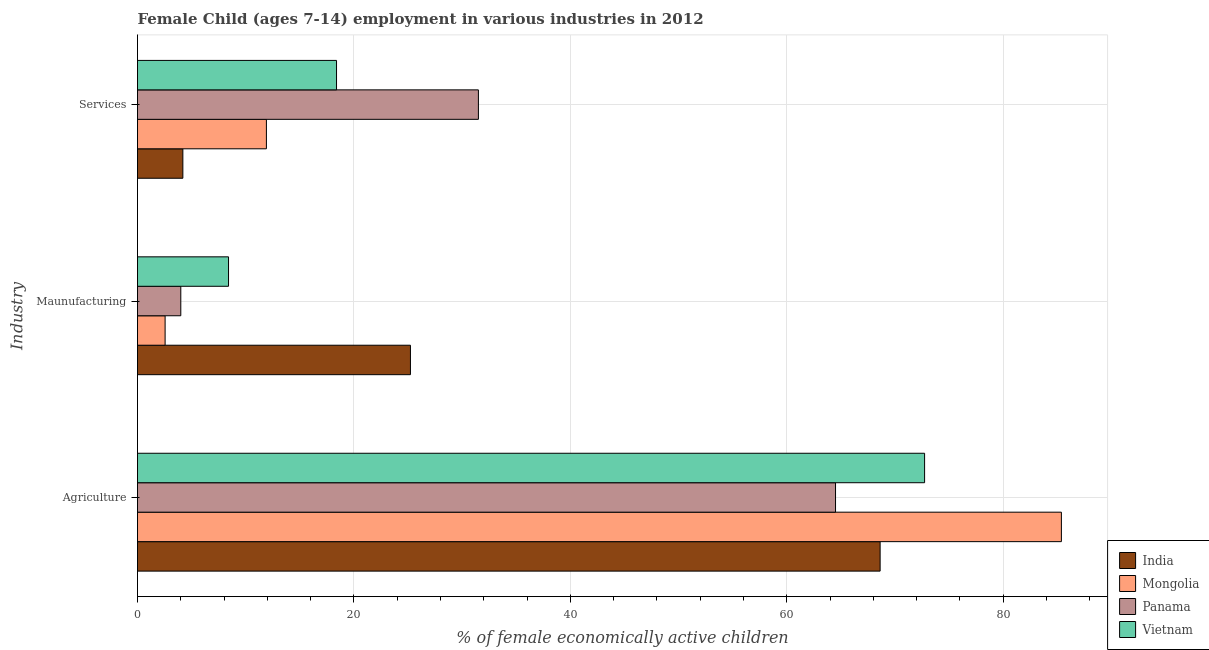How many different coloured bars are there?
Make the answer very short. 4. How many groups of bars are there?
Offer a very short reply. 3. Are the number of bars per tick equal to the number of legend labels?
Your answer should be compact. Yes. How many bars are there on the 2nd tick from the top?
Keep it short and to the point. 4. What is the label of the 3rd group of bars from the top?
Offer a terse response. Agriculture. What is the percentage of economically active children in agriculture in India?
Ensure brevity in your answer.  68.62. Across all countries, what is the maximum percentage of economically active children in manufacturing?
Your answer should be very brief. 25.22. Across all countries, what is the minimum percentage of economically active children in services?
Your response must be concise. 4.19. In which country was the percentage of economically active children in agriculture maximum?
Keep it short and to the point. Mongolia. In which country was the percentage of economically active children in services minimum?
Offer a terse response. India. What is the total percentage of economically active children in manufacturing in the graph?
Offer a very short reply. 40.18. What is the difference between the percentage of economically active children in services in India and that in Mongolia?
Provide a succinct answer. -7.72. What is the difference between the percentage of economically active children in manufacturing in India and the percentage of economically active children in services in Mongolia?
Provide a succinct answer. 13.31. What is the average percentage of economically active children in services per country?
Ensure brevity in your answer.  16.5. What is the difference between the percentage of economically active children in agriculture and percentage of economically active children in services in Vietnam?
Your answer should be compact. 54.34. What is the ratio of the percentage of economically active children in services in Vietnam to that in Mongolia?
Offer a terse response. 1.54. What is the difference between the highest and the second highest percentage of economically active children in services?
Provide a short and direct response. 13.11. What is the difference between the highest and the lowest percentage of economically active children in agriculture?
Offer a very short reply. 20.87. In how many countries, is the percentage of economically active children in manufacturing greater than the average percentage of economically active children in manufacturing taken over all countries?
Your answer should be very brief. 1. Is the sum of the percentage of economically active children in manufacturing in Vietnam and India greater than the maximum percentage of economically active children in services across all countries?
Provide a succinct answer. Yes. What does the 2nd bar from the top in Services represents?
Make the answer very short. Panama. What does the 1st bar from the bottom in Services represents?
Provide a succinct answer. India. Is it the case that in every country, the sum of the percentage of economically active children in agriculture and percentage of economically active children in manufacturing is greater than the percentage of economically active children in services?
Provide a short and direct response. Yes. How many bars are there?
Your response must be concise. 12. How many countries are there in the graph?
Keep it short and to the point. 4. Are the values on the major ticks of X-axis written in scientific E-notation?
Your answer should be very brief. No. Where does the legend appear in the graph?
Give a very brief answer. Bottom right. How are the legend labels stacked?
Provide a short and direct response. Vertical. What is the title of the graph?
Provide a succinct answer. Female Child (ages 7-14) employment in various industries in 2012. Does "Libya" appear as one of the legend labels in the graph?
Ensure brevity in your answer.  No. What is the label or title of the X-axis?
Your response must be concise. % of female economically active children. What is the label or title of the Y-axis?
Make the answer very short. Industry. What is the % of female economically active children in India in Agriculture?
Ensure brevity in your answer.  68.62. What is the % of female economically active children in Mongolia in Agriculture?
Provide a short and direct response. 85.37. What is the % of female economically active children of Panama in Agriculture?
Make the answer very short. 64.5. What is the % of female economically active children of Vietnam in Agriculture?
Make the answer very short. 72.73. What is the % of female economically active children of India in Maunufacturing?
Keep it short and to the point. 25.22. What is the % of female economically active children of Mongolia in Maunufacturing?
Ensure brevity in your answer.  2.55. What is the % of female economically active children in Panama in Maunufacturing?
Make the answer very short. 4. What is the % of female economically active children in Vietnam in Maunufacturing?
Make the answer very short. 8.41. What is the % of female economically active children in India in Services?
Make the answer very short. 4.19. What is the % of female economically active children of Mongolia in Services?
Provide a succinct answer. 11.91. What is the % of female economically active children in Panama in Services?
Ensure brevity in your answer.  31.5. What is the % of female economically active children in Vietnam in Services?
Offer a terse response. 18.39. Across all Industry, what is the maximum % of female economically active children in India?
Ensure brevity in your answer.  68.62. Across all Industry, what is the maximum % of female economically active children in Mongolia?
Offer a very short reply. 85.37. Across all Industry, what is the maximum % of female economically active children in Panama?
Your answer should be compact. 64.5. Across all Industry, what is the maximum % of female economically active children in Vietnam?
Provide a short and direct response. 72.73. Across all Industry, what is the minimum % of female economically active children in India?
Give a very brief answer. 4.19. Across all Industry, what is the minimum % of female economically active children of Mongolia?
Your answer should be very brief. 2.55. Across all Industry, what is the minimum % of female economically active children of Vietnam?
Provide a short and direct response. 8.41. What is the total % of female economically active children in India in the graph?
Your response must be concise. 98.03. What is the total % of female economically active children in Mongolia in the graph?
Keep it short and to the point. 99.83. What is the total % of female economically active children in Panama in the graph?
Your response must be concise. 100. What is the total % of female economically active children in Vietnam in the graph?
Your answer should be very brief. 99.53. What is the difference between the % of female economically active children in India in Agriculture and that in Maunufacturing?
Ensure brevity in your answer.  43.4. What is the difference between the % of female economically active children of Mongolia in Agriculture and that in Maunufacturing?
Your response must be concise. 82.82. What is the difference between the % of female economically active children in Panama in Agriculture and that in Maunufacturing?
Your response must be concise. 60.5. What is the difference between the % of female economically active children of Vietnam in Agriculture and that in Maunufacturing?
Keep it short and to the point. 64.32. What is the difference between the % of female economically active children of India in Agriculture and that in Services?
Your response must be concise. 64.43. What is the difference between the % of female economically active children in Mongolia in Agriculture and that in Services?
Your response must be concise. 73.46. What is the difference between the % of female economically active children of Vietnam in Agriculture and that in Services?
Provide a short and direct response. 54.34. What is the difference between the % of female economically active children in India in Maunufacturing and that in Services?
Your response must be concise. 21.03. What is the difference between the % of female economically active children of Mongolia in Maunufacturing and that in Services?
Make the answer very short. -9.36. What is the difference between the % of female economically active children of Panama in Maunufacturing and that in Services?
Your answer should be very brief. -27.5. What is the difference between the % of female economically active children in Vietnam in Maunufacturing and that in Services?
Offer a terse response. -9.98. What is the difference between the % of female economically active children in India in Agriculture and the % of female economically active children in Mongolia in Maunufacturing?
Offer a terse response. 66.07. What is the difference between the % of female economically active children of India in Agriculture and the % of female economically active children of Panama in Maunufacturing?
Your answer should be compact. 64.62. What is the difference between the % of female economically active children of India in Agriculture and the % of female economically active children of Vietnam in Maunufacturing?
Offer a terse response. 60.21. What is the difference between the % of female economically active children in Mongolia in Agriculture and the % of female economically active children in Panama in Maunufacturing?
Your response must be concise. 81.37. What is the difference between the % of female economically active children of Mongolia in Agriculture and the % of female economically active children of Vietnam in Maunufacturing?
Provide a succinct answer. 76.96. What is the difference between the % of female economically active children in Panama in Agriculture and the % of female economically active children in Vietnam in Maunufacturing?
Make the answer very short. 56.09. What is the difference between the % of female economically active children of India in Agriculture and the % of female economically active children of Mongolia in Services?
Ensure brevity in your answer.  56.71. What is the difference between the % of female economically active children in India in Agriculture and the % of female economically active children in Panama in Services?
Make the answer very short. 37.12. What is the difference between the % of female economically active children of India in Agriculture and the % of female economically active children of Vietnam in Services?
Ensure brevity in your answer.  50.23. What is the difference between the % of female economically active children in Mongolia in Agriculture and the % of female economically active children in Panama in Services?
Give a very brief answer. 53.87. What is the difference between the % of female economically active children of Mongolia in Agriculture and the % of female economically active children of Vietnam in Services?
Provide a succinct answer. 66.98. What is the difference between the % of female economically active children of Panama in Agriculture and the % of female economically active children of Vietnam in Services?
Offer a terse response. 46.11. What is the difference between the % of female economically active children in India in Maunufacturing and the % of female economically active children in Mongolia in Services?
Make the answer very short. 13.31. What is the difference between the % of female economically active children of India in Maunufacturing and the % of female economically active children of Panama in Services?
Your answer should be very brief. -6.28. What is the difference between the % of female economically active children of India in Maunufacturing and the % of female economically active children of Vietnam in Services?
Provide a short and direct response. 6.83. What is the difference between the % of female economically active children in Mongolia in Maunufacturing and the % of female economically active children in Panama in Services?
Keep it short and to the point. -28.95. What is the difference between the % of female economically active children in Mongolia in Maunufacturing and the % of female economically active children in Vietnam in Services?
Your answer should be very brief. -15.84. What is the difference between the % of female economically active children in Panama in Maunufacturing and the % of female economically active children in Vietnam in Services?
Your answer should be very brief. -14.39. What is the average % of female economically active children of India per Industry?
Give a very brief answer. 32.68. What is the average % of female economically active children of Mongolia per Industry?
Provide a short and direct response. 33.28. What is the average % of female economically active children of Panama per Industry?
Keep it short and to the point. 33.33. What is the average % of female economically active children in Vietnam per Industry?
Your answer should be compact. 33.18. What is the difference between the % of female economically active children in India and % of female economically active children in Mongolia in Agriculture?
Provide a short and direct response. -16.75. What is the difference between the % of female economically active children of India and % of female economically active children of Panama in Agriculture?
Make the answer very short. 4.12. What is the difference between the % of female economically active children of India and % of female economically active children of Vietnam in Agriculture?
Your response must be concise. -4.11. What is the difference between the % of female economically active children in Mongolia and % of female economically active children in Panama in Agriculture?
Your response must be concise. 20.87. What is the difference between the % of female economically active children in Mongolia and % of female economically active children in Vietnam in Agriculture?
Provide a succinct answer. 12.64. What is the difference between the % of female economically active children in Panama and % of female economically active children in Vietnam in Agriculture?
Keep it short and to the point. -8.23. What is the difference between the % of female economically active children in India and % of female economically active children in Mongolia in Maunufacturing?
Your response must be concise. 22.67. What is the difference between the % of female economically active children in India and % of female economically active children in Panama in Maunufacturing?
Your response must be concise. 21.22. What is the difference between the % of female economically active children of India and % of female economically active children of Vietnam in Maunufacturing?
Give a very brief answer. 16.81. What is the difference between the % of female economically active children in Mongolia and % of female economically active children in Panama in Maunufacturing?
Give a very brief answer. -1.45. What is the difference between the % of female economically active children of Mongolia and % of female economically active children of Vietnam in Maunufacturing?
Make the answer very short. -5.86. What is the difference between the % of female economically active children of Panama and % of female economically active children of Vietnam in Maunufacturing?
Your answer should be very brief. -4.41. What is the difference between the % of female economically active children of India and % of female economically active children of Mongolia in Services?
Offer a terse response. -7.72. What is the difference between the % of female economically active children of India and % of female economically active children of Panama in Services?
Keep it short and to the point. -27.31. What is the difference between the % of female economically active children in India and % of female economically active children in Vietnam in Services?
Your response must be concise. -14.2. What is the difference between the % of female economically active children in Mongolia and % of female economically active children in Panama in Services?
Ensure brevity in your answer.  -19.59. What is the difference between the % of female economically active children in Mongolia and % of female economically active children in Vietnam in Services?
Offer a very short reply. -6.48. What is the difference between the % of female economically active children of Panama and % of female economically active children of Vietnam in Services?
Offer a very short reply. 13.11. What is the ratio of the % of female economically active children in India in Agriculture to that in Maunufacturing?
Offer a terse response. 2.72. What is the ratio of the % of female economically active children of Mongolia in Agriculture to that in Maunufacturing?
Give a very brief answer. 33.48. What is the ratio of the % of female economically active children of Panama in Agriculture to that in Maunufacturing?
Your answer should be compact. 16.12. What is the ratio of the % of female economically active children of Vietnam in Agriculture to that in Maunufacturing?
Your answer should be very brief. 8.65. What is the ratio of the % of female economically active children of India in Agriculture to that in Services?
Keep it short and to the point. 16.38. What is the ratio of the % of female economically active children in Mongolia in Agriculture to that in Services?
Your answer should be very brief. 7.17. What is the ratio of the % of female economically active children of Panama in Agriculture to that in Services?
Give a very brief answer. 2.05. What is the ratio of the % of female economically active children of Vietnam in Agriculture to that in Services?
Your answer should be very brief. 3.95. What is the ratio of the % of female economically active children of India in Maunufacturing to that in Services?
Keep it short and to the point. 6.02. What is the ratio of the % of female economically active children of Mongolia in Maunufacturing to that in Services?
Keep it short and to the point. 0.21. What is the ratio of the % of female economically active children in Panama in Maunufacturing to that in Services?
Your response must be concise. 0.13. What is the ratio of the % of female economically active children in Vietnam in Maunufacturing to that in Services?
Provide a succinct answer. 0.46. What is the difference between the highest and the second highest % of female economically active children in India?
Offer a terse response. 43.4. What is the difference between the highest and the second highest % of female economically active children in Mongolia?
Your answer should be very brief. 73.46. What is the difference between the highest and the second highest % of female economically active children in Vietnam?
Offer a very short reply. 54.34. What is the difference between the highest and the lowest % of female economically active children in India?
Provide a succinct answer. 64.43. What is the difference between the highest and the lowest % of female economically active children of Mongolia?
Your response must be concise. 82.82. What is the difference between the highest and the lowest % of female economically active children of Panama?
Provide a succinct answer. 60.5. What is the difference between the highest and the lowest % of female economically active children in Vietnam?
Give a very brief answer. 64.32. 